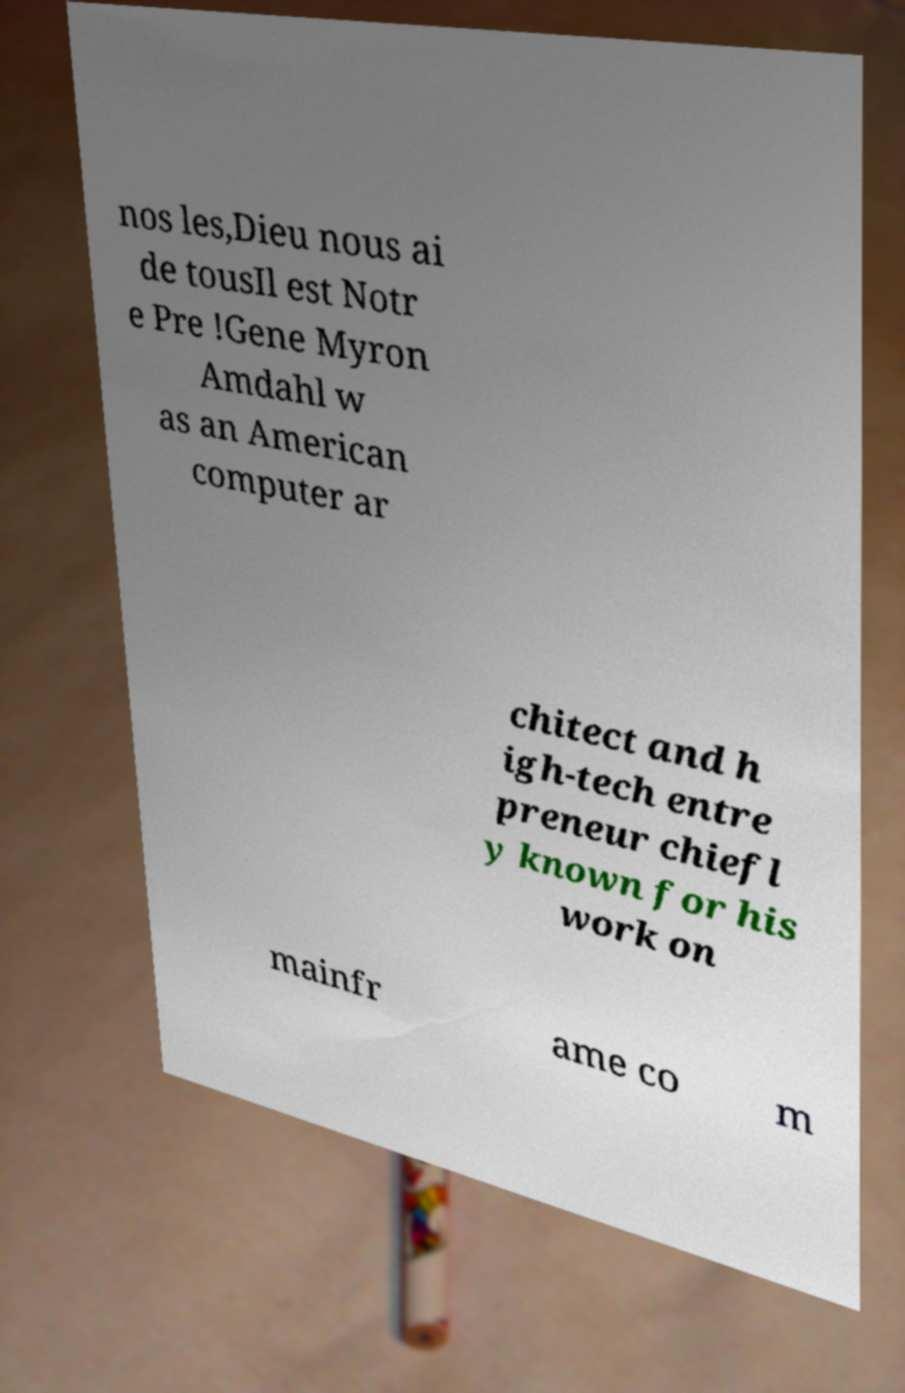I need the written content from this picture converted into text. Can you do that? nos les,Dieu nous ai de tousIl est Notr e Pre !Gene Myron Amdahl w as an American computer ar chitect and h igh-tech entre preneur chiefl y known for his work on mainfr ame co m 